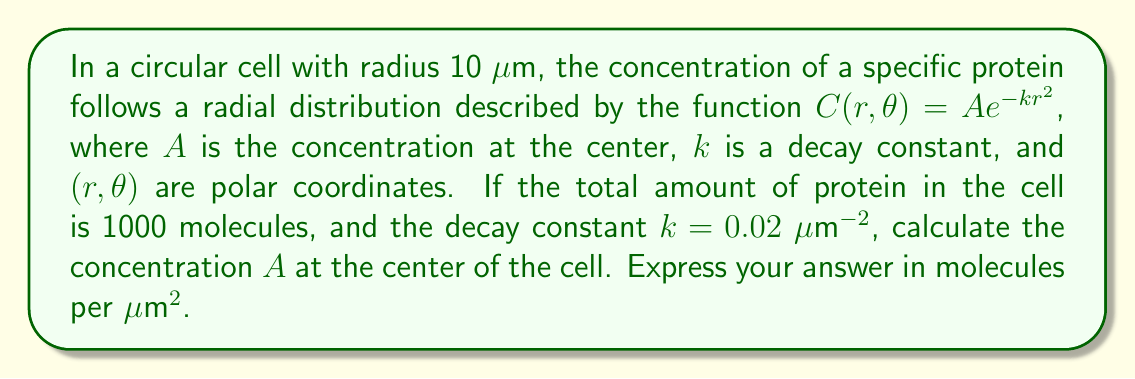Can you solve this math problem? To solve this problem, we need to follow these steps:

1) The total amount of protein in the cell is given by the volume integral of the concentration function over the entire cell. In polar coordinates, this is:

   $$N = \int_0^{2\pi} \int_0^R C(r,\theta) r dr d\theta$$

   where $N$ is the total number of molecules and $R$ is the radius of the cell.

2) Substituting the given function and limits:

   $$1000 = \int_0^{2\pi} \int_0^{10} A e^{-0.02r^2} r dr d\theta$$

3) The function doesn't depend on $\theta$, so we can immediately integrate over $\theta$:

   $$1000 = 2\pi A \int_0^{10} e^{-0.02r^2} r dr$$

4) To solve this integral, we can use the substitution $u = 0.02r^2$, $du = 0.04r dr$, or $r dr = \frac{du}{0.04}$:

   $$1000 = 2\pi A \int_0^2 e^{-u} \frac{du}{0.04} = \frac{\pi A}{0.02} \int_0^2 e^{-u} du$$

5) Evaluating the integral:

   $$1000 = \frac{\pi A}{0.02} [-e^{-u}]_0^2 = \frac{\pi A}{0.02} (1 - e^{-2})$$

6) Solving for $A$:

   $$A = \frac{1000 \cdot 0.02}{\pi (1 - e^{-2})} \approx 6.37 \text{ molecules/μm}^2$$
Answer: $A \approx 6.37 \text{ molecules/μm}^2$ 